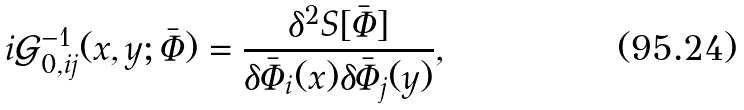Convert formula to latex. <formula><loc_0><loc_0><loc_500><loc_500>i \mathcal { G } ^ { - 1 } _ { 0 , i j } ( x , y ; \bar { \Phi } ) = \frac { \delta ^ { 2 } S [ \bar { \Phi } ] } { \delta \bar { \Phi } _ { i } ( x ) \delta \bar { \Phi } _ { j } ( y ) } ,</formula> 